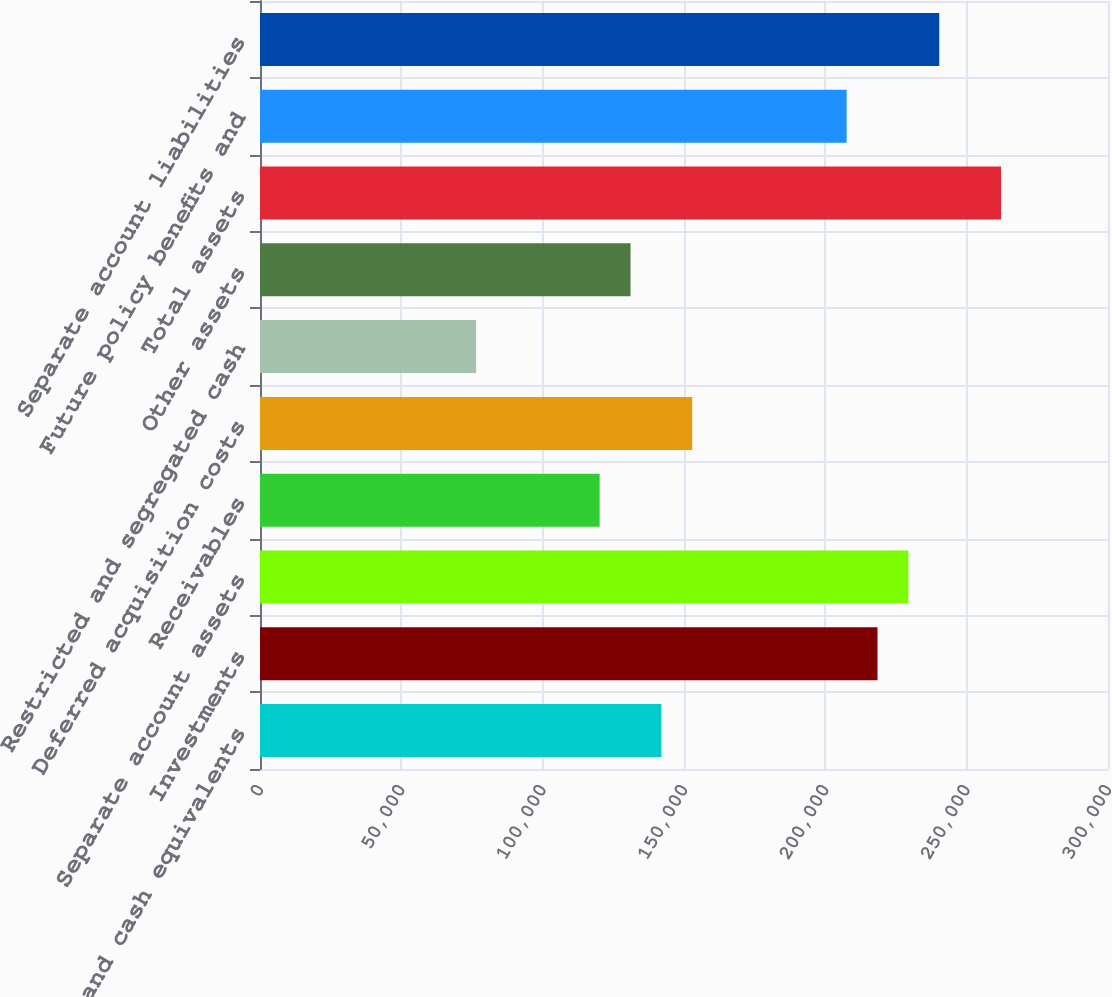Convert chart. <chart><loc_0><loc_0><loc_500><loc_500><bar_chart><fcel>Cash and cash equivalents<fcel>Investments<fcel>Separate account assets<fcel>Receivables<fcel>Deferred acquisition costs<fcel>Restricted and segregated cash<fcel>Other assets<fcel>Total assets<fcel>Future policy benefits and<fcel>Separate account liabilities<nl><fcel>141998<fcel>218457<fcel>229380<fcel>120153<fcel>152921<fcel>76461.9<fcel>131075<fcel>262148<fcel>207534<fcel>240302<nl></chart> 